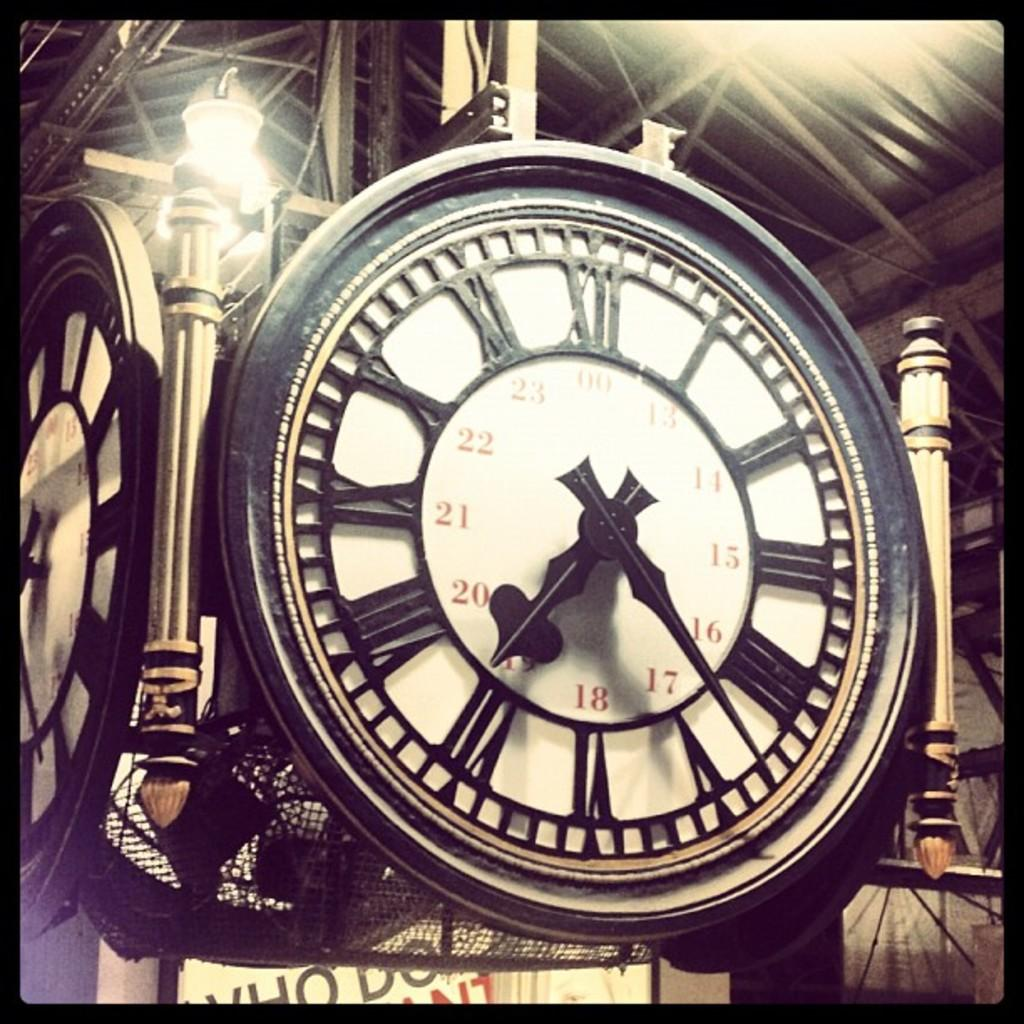<image>
Describe the image concisely. Clock which shows the hands at 17 and 19. 